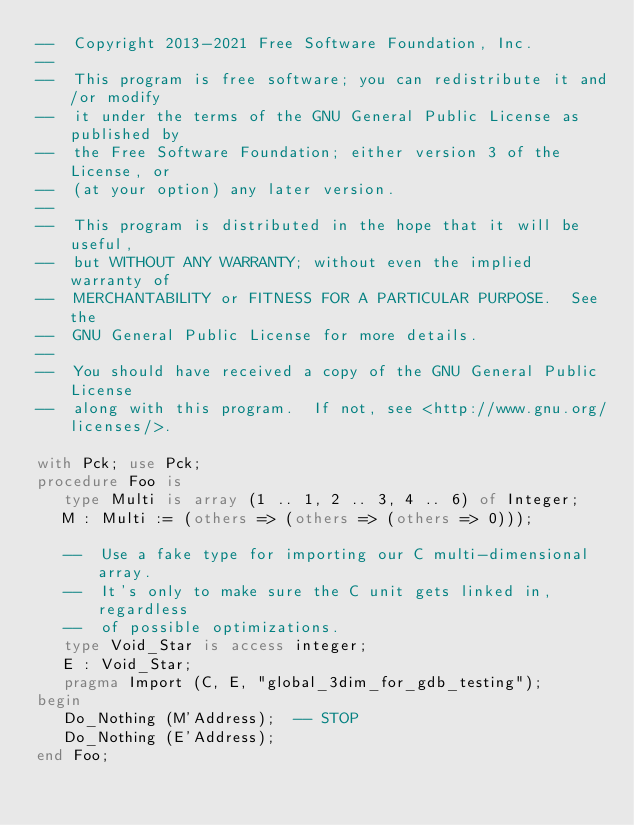<code> <loc_0><loc_0><loc_500><loc_500><_Ada_>--  Copyright 2013-2021 Free Software Foundation, Inc.
--
--  This program is free software; you can redistribute it and/or modify
--  it under the terms of the GNU General Public License as published by
--  the Free Software Foundation; either version 3 of the License, or
--  (at your option) any later version.
--
--  This program is distributed in the hope that it will be useful,
--  but WITHOUT ANY WARRANTY; without even the implied warranty of
--  MERCHANTABILITY or FITNESS FOR A PARTICULAR PURPOSE.  See the
--  GNU General Public License for more details.
--
--  You should have received a copy of the GNU General Public License
--  along with this program.  If not, see <http://www.gnu.org/licenses/>.

with Pck; use Pck;
procedure Foo is
   type Multi is array (1 .. 1, 2 .. 3, 4 .. 6) of Integer;
   M : Multi := (others => (others => (others => 0)));

   --  Use a fake type for importing our C multi-dimensional array.
   --  It's only to make sure the C unit gets linked in, regardless
   --  of possible optimizations.
   type Void_Star is access integer;
   E : Void_Star;
   pragma Import (C, E, "global_3dim_for_gdb_testing");
begin
   Do_Nothing (M'Address);  -- STOP
   Do_Nothing (E'Address);
end Foo;
</code> 